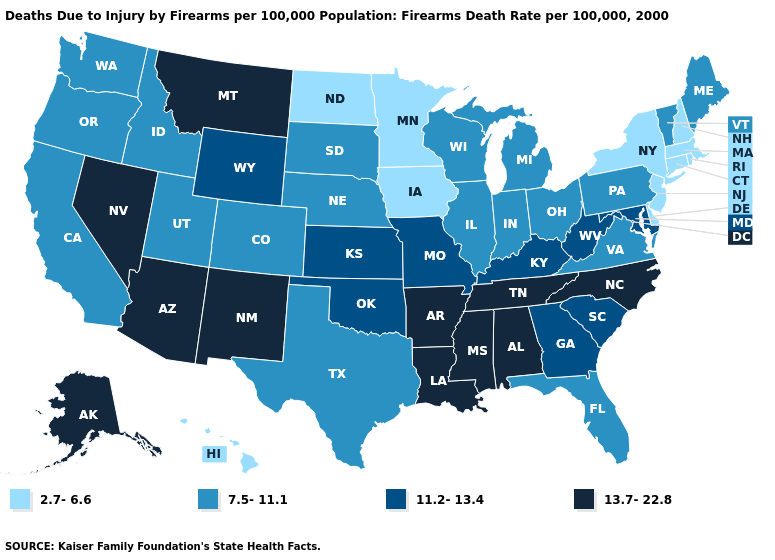What is the highest value in states that border Kentucky?
Answer briefly. 13.7-22.8. What is the lowest value in the USA?
Answer briefly. 2.7-6.6. What is the value of Maine?
Keep it brief. 7.5-11.1. Does the first symbol in the legend represent the smallest category?
Give a very brief answer. Yes. Which states have the lowest value in the Northeast?
Be succinct. Connecticut, Massachusetts, New Hampshire, New Jersey, New York, Rhode Island. Does Oklahoma have the highest value in the USA?
Short answer required. No. Name the states that have a value in the range 7.5-11.1?
Keep it brief. California, Colorado, Florida, Idaho, Illinois, Indiana, Maine, Michigan, Nebraska, Ohio, Oregon, Pennsylvania, South Dakota, Texas, Utah, Vermont, Virginia, Washington, Wisconsin. What is the value of Michigan?
Quick response, please. 7.5-11.1. What is the value of West Virginia?
Concise answer only. 11.2-13.4. Which states have the lowest value in the USA?
Concise answer only. Connecticut, Delaware, Hawaii, Iowa, Massachusetts, Minnesota, New Hampshire, New Jersey, New York, North Dakota, Rhode Island. Among the states that border Texas , which have the lowest value?
Write a very short answer. Oklahoma. Among the states that border Illinois , which have the lowest value?
Keep it brief. Iowa. Among the states that border Mississippi , which have the lowest value?
Concise answer only. Alabama, Arkansas, Louisiana, Tennessee. What is the lowest value in the West?
Quick response, please. 2.7-6.6. What is the highest value in the Northeast ?
Be succinct. 7.5-11.1. 